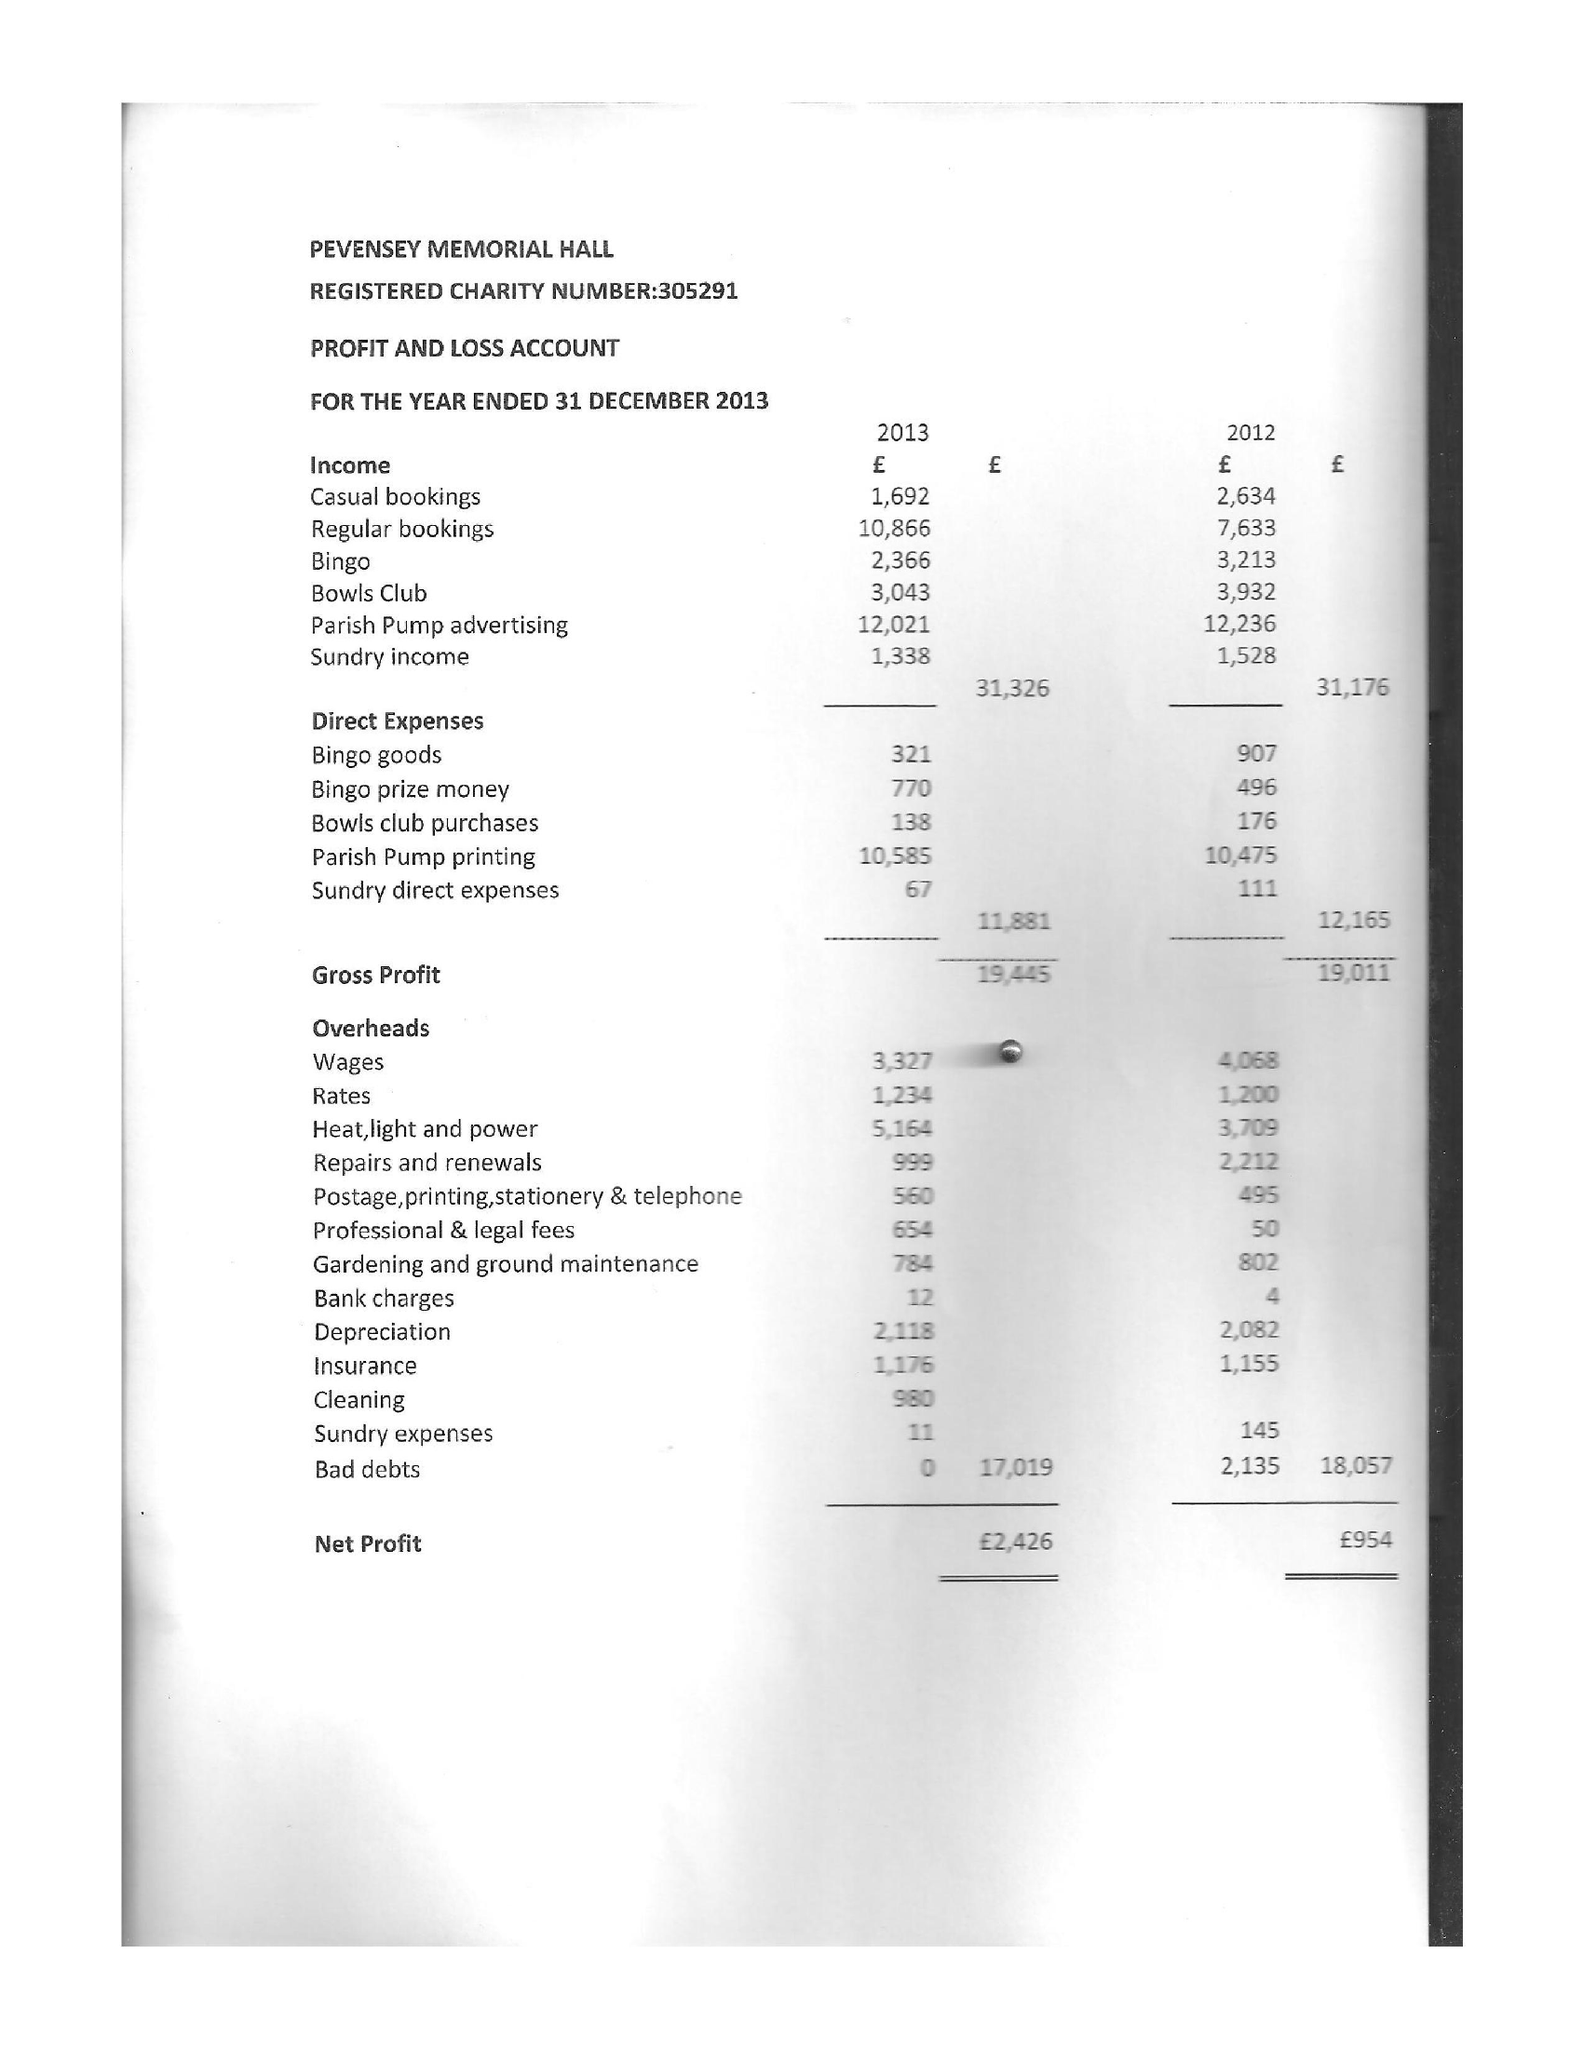What is the value for the address__post_town?
Answer the question using a single word or phrase. PEVENSEY 